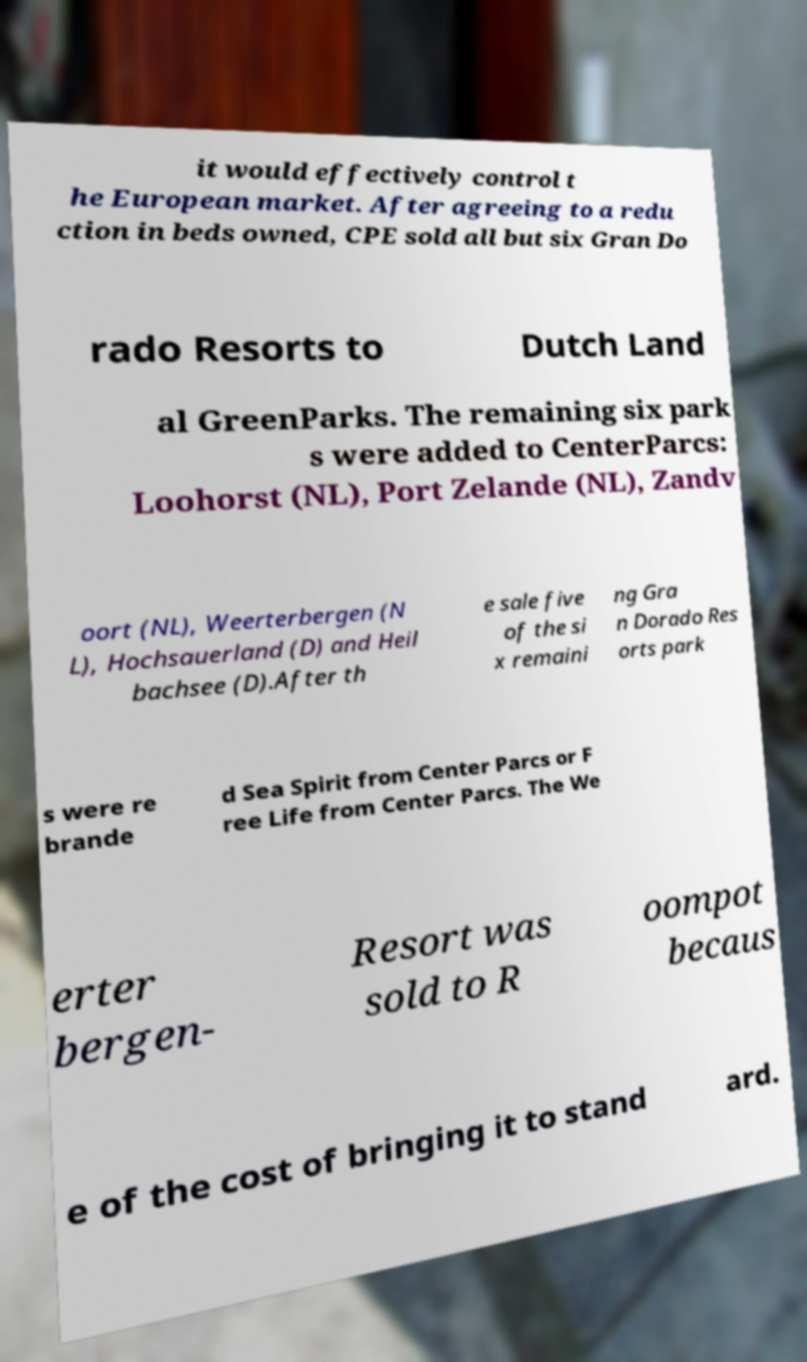I need the written content from this picture converted into text. Can you do that? it would effectively control t he European market. After agreeing to a redu ction in beds owned, CPE sold all but six Gran Do rado Resorts to Dutch Land al GreenParks. The remaining six park s were added to CenterParcs: Loohorst (NL), Port Zelande (NL), Zandv oort (NL), Weerterbergen (N L), Hochsauerland (D) and Heil bachsee (D).After th e sale five of the si x remaini ng Gra n Dorado Res orts park s were re brande d Sea Spirit from Center Parcs or F ree Life from Center Parcs. The We erter bergen- Resort was sold to R oompot becaus e of the cost of bringing it to stand ard. 